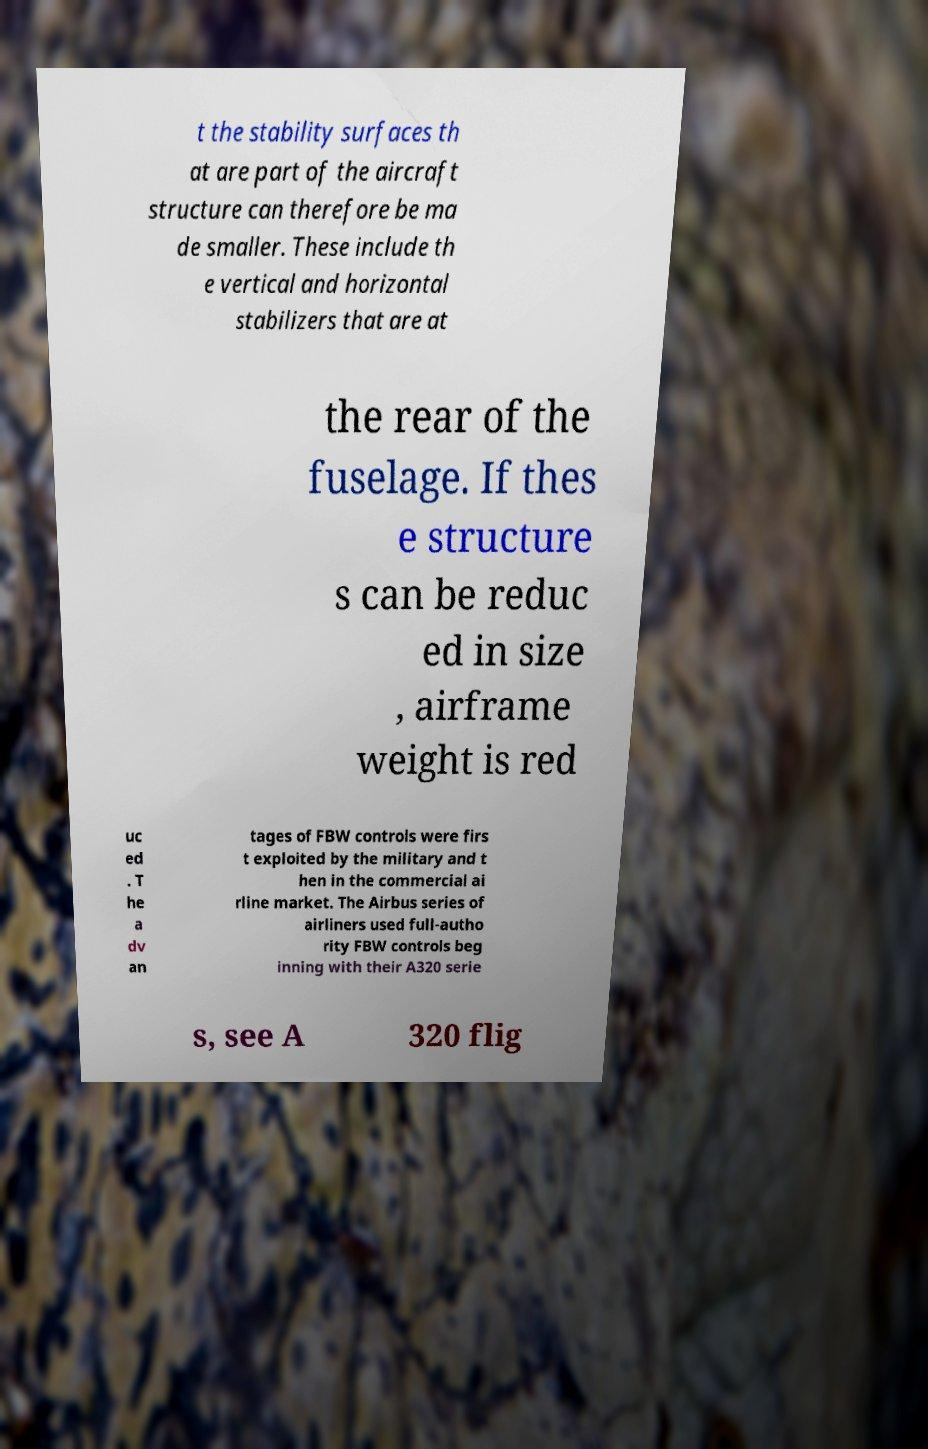Can you accurately transcribe the text from the provided image for me? t the stability surfaces th at are part of the aircraft structure can therefore be ma de smaller. These include th e vertical and horizontal stabilizers that are at the rear of the fuselage. If thes e structure s can be reduc ed in size , airframe weight is red uc ed . T he a dv an tages of FBW controls were firs t exploited by the military and t hen in the commercial ai rline market. The Airbus series of airliners used full-autho rity FBW controls beg inning with their A320 serie s, see A 320 flig 